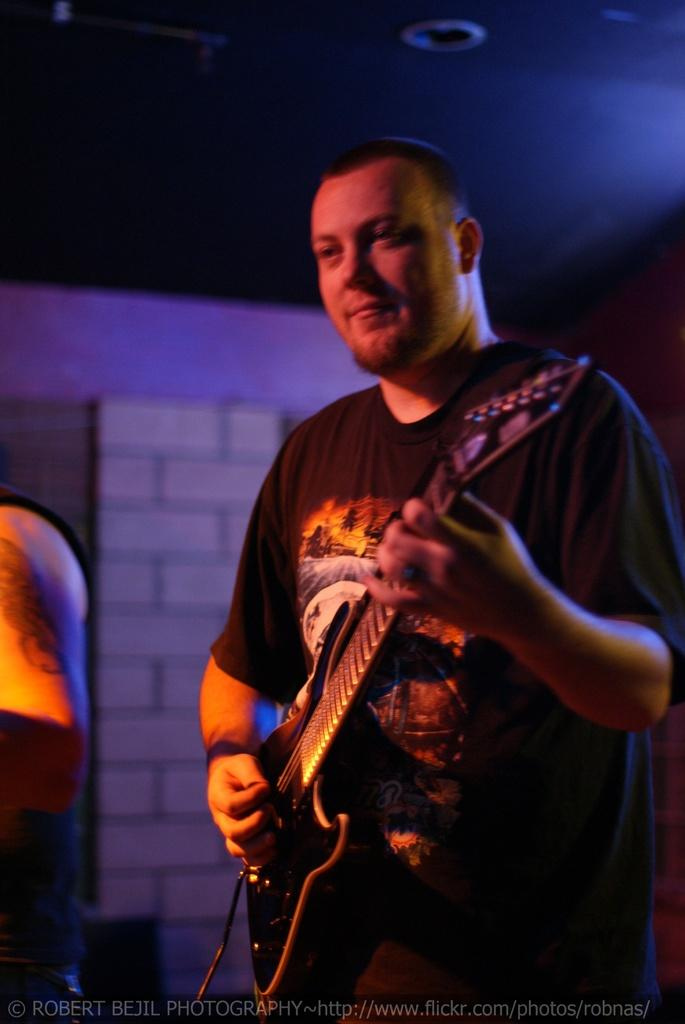What is the man in the image holding? The man is holding a guitar in the image. Can you describe the other person in the image? There is another person standing in the image. What can be seen in the background of the image? There is a wall in the background of the image. Is there any additional information about the image itself? Yes, there is a watermark on the image. Can you tell me how many socks are visible in the image? There are no socks visible in the image. Is there a vase present in the image? There is no vase present in the image. 